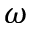<formula> <loc_0><loc_0><loc_500><loc_500>\omega</formula> 